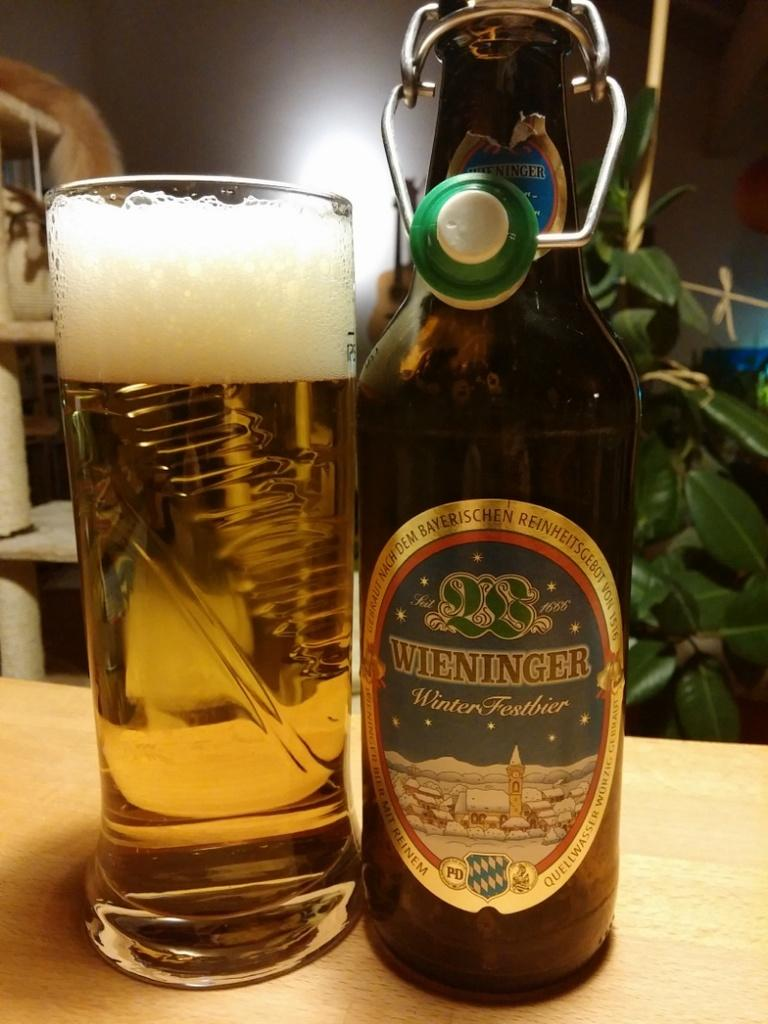<image>
Describe the image concisely. A full glass next to a bottle of Wieninger Winterfestbier 